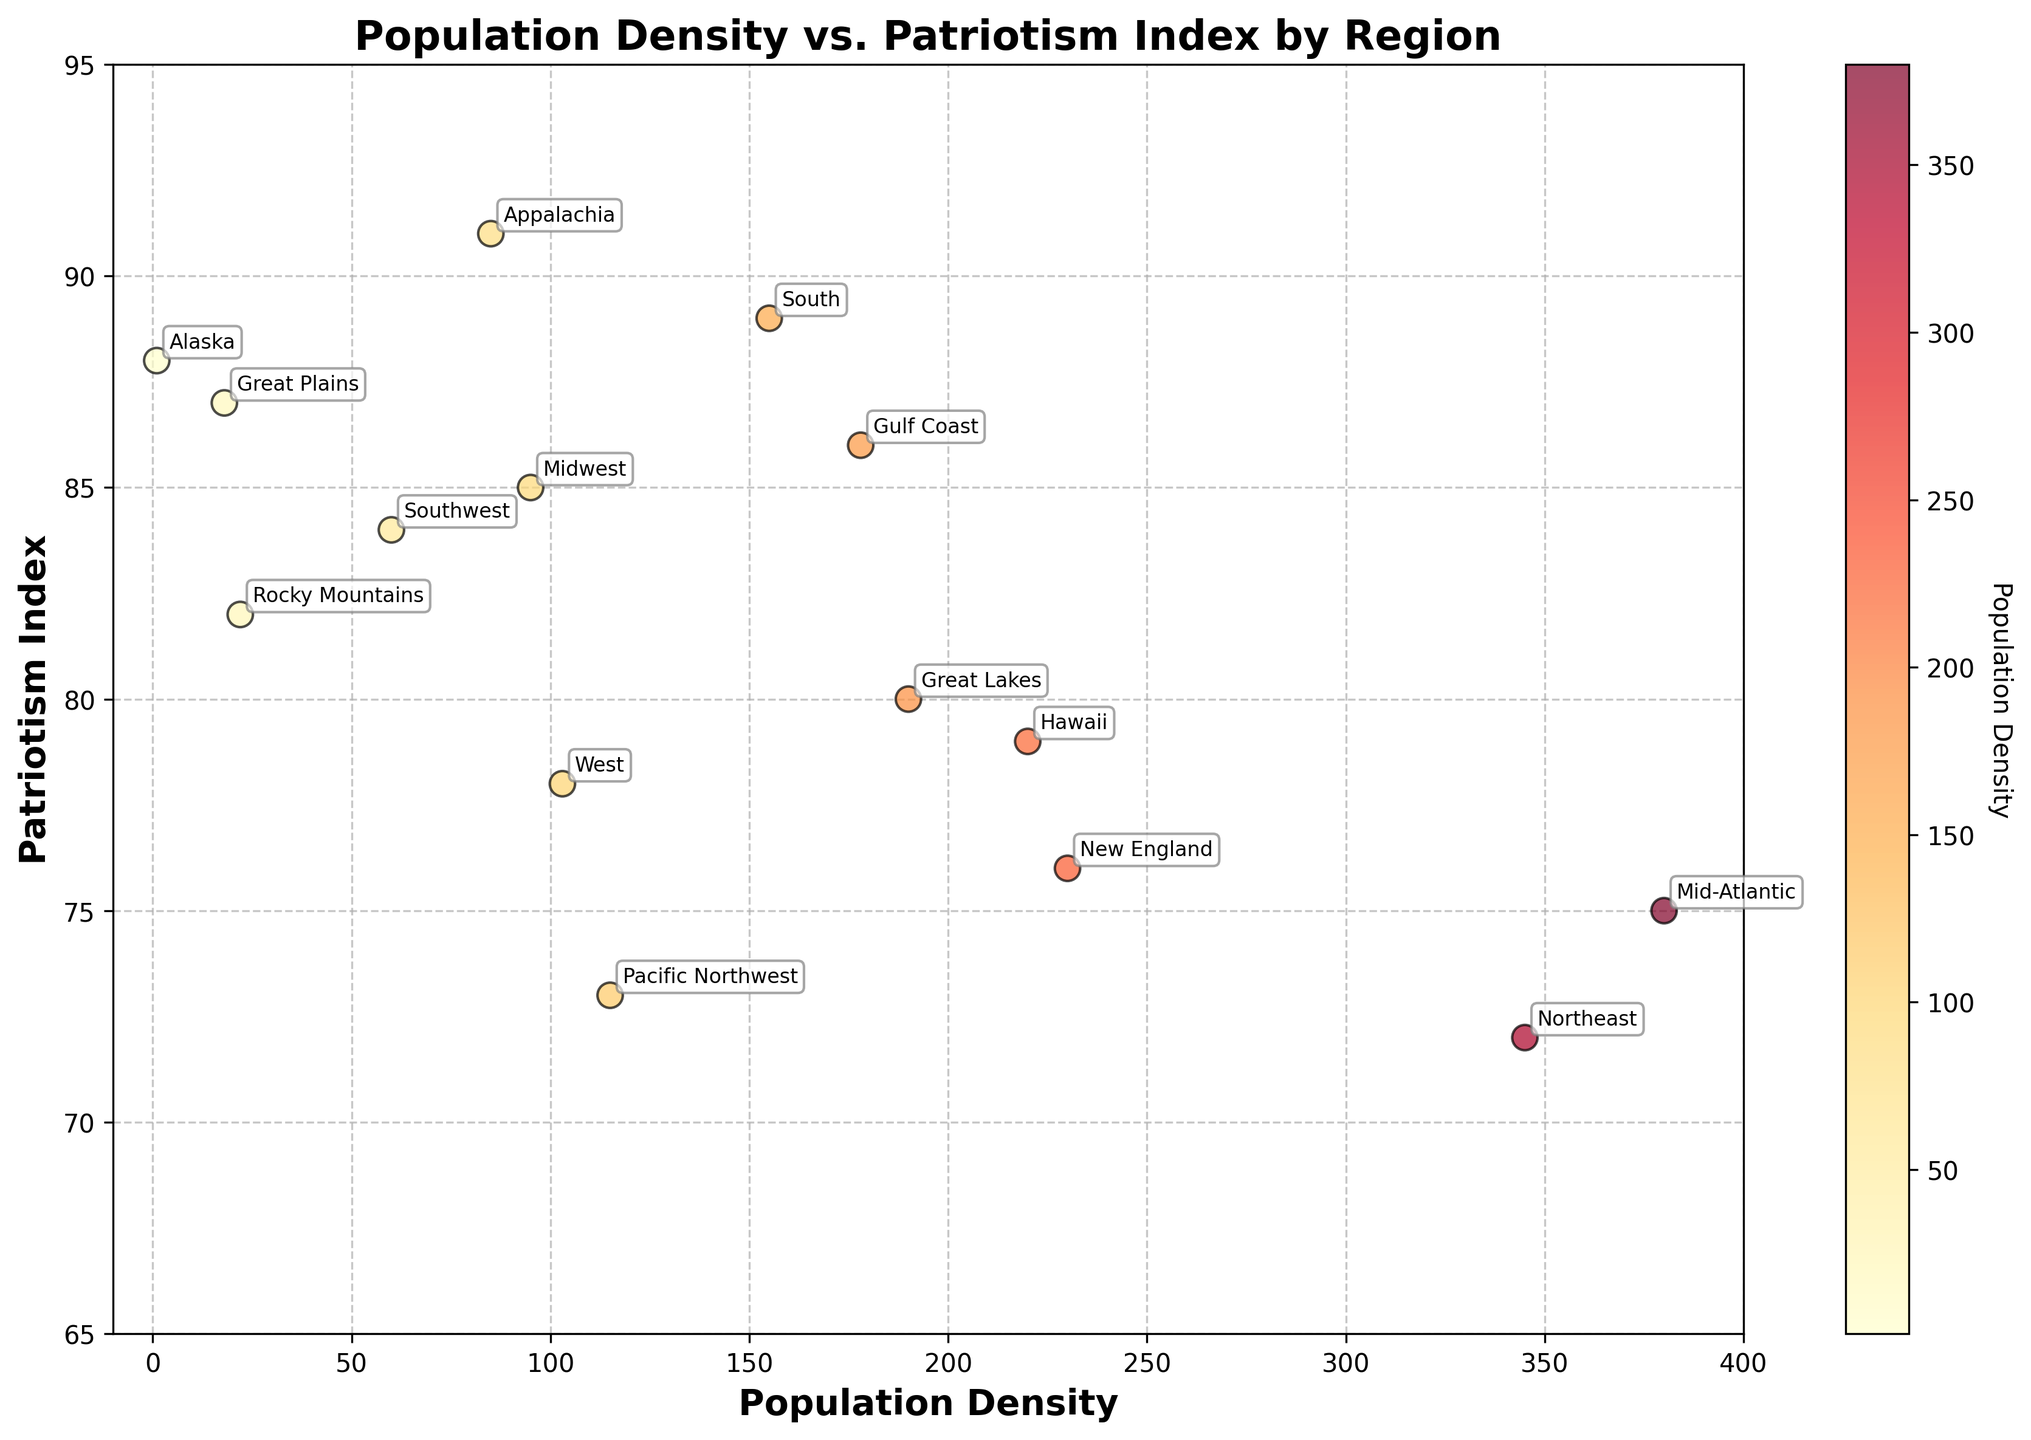What's the title of the figure? The title of the figure is displayed at the top and provides a summary of what the graph is about.
Answer: Population Density vs. Patriotism Index by Region Which region has the highest population density? To find the region with the highest population density, look for the data point located furthest along the x-axis.
Answer: Mid-Atlantic What is the Patriotism Index of Alaska? Locate Alaska on the plot, then read the corresponding Patriotism Index value on the y-axis.
Answer: 88 How many regions have a Population Density greater than 200? Count the data points with Population Density values greater than 200 on the x-axis.
Answer: 3 Which region has the highest combination of Population Density and Patriotism Index? Add the Population Density and Patriotism Index for each region, then compare the sums to find the highest one.
Answer: Gulf Coast (Population Density: 178, Patriotism Index: 86, Sum: 264) What is the average Patriotism Index of the four most populous regions? Identify the four regions with the highest Population Density, read their Patriotism Index values, sum them, and then divide by 4. The regions are Mid-Atlantic (75), New England (76), Hawaii (79), and Great Lakes (80). Sum = 75 + 76 + 79 + 80 = 310. Average = 310 / 4 = 77.5
Answer: 77.5 Is there a region with both low Population Density and high Patriotism Index? To find this, look for a region towards the left (low Population Density) but high on the y-axis (high Patriotism Index). The Great Plains fits this criteria with a Population Density of 18 and Patriotism Index of 87.
Answer: Yes, Great Plains Which region has a Patriotism Index closest to 85? Look for the data point that is nearest to the y-axis value of 85.
Answer: Midwest (Patriotism Index: 85) Compare the Population Density of the South and the Midwest. Which one is higher? Locate the South and the Midwest on the x-axis to compare their Population Densities directly. The South has a Population Density of 155, while the Midwest has 95.
Answer: South 